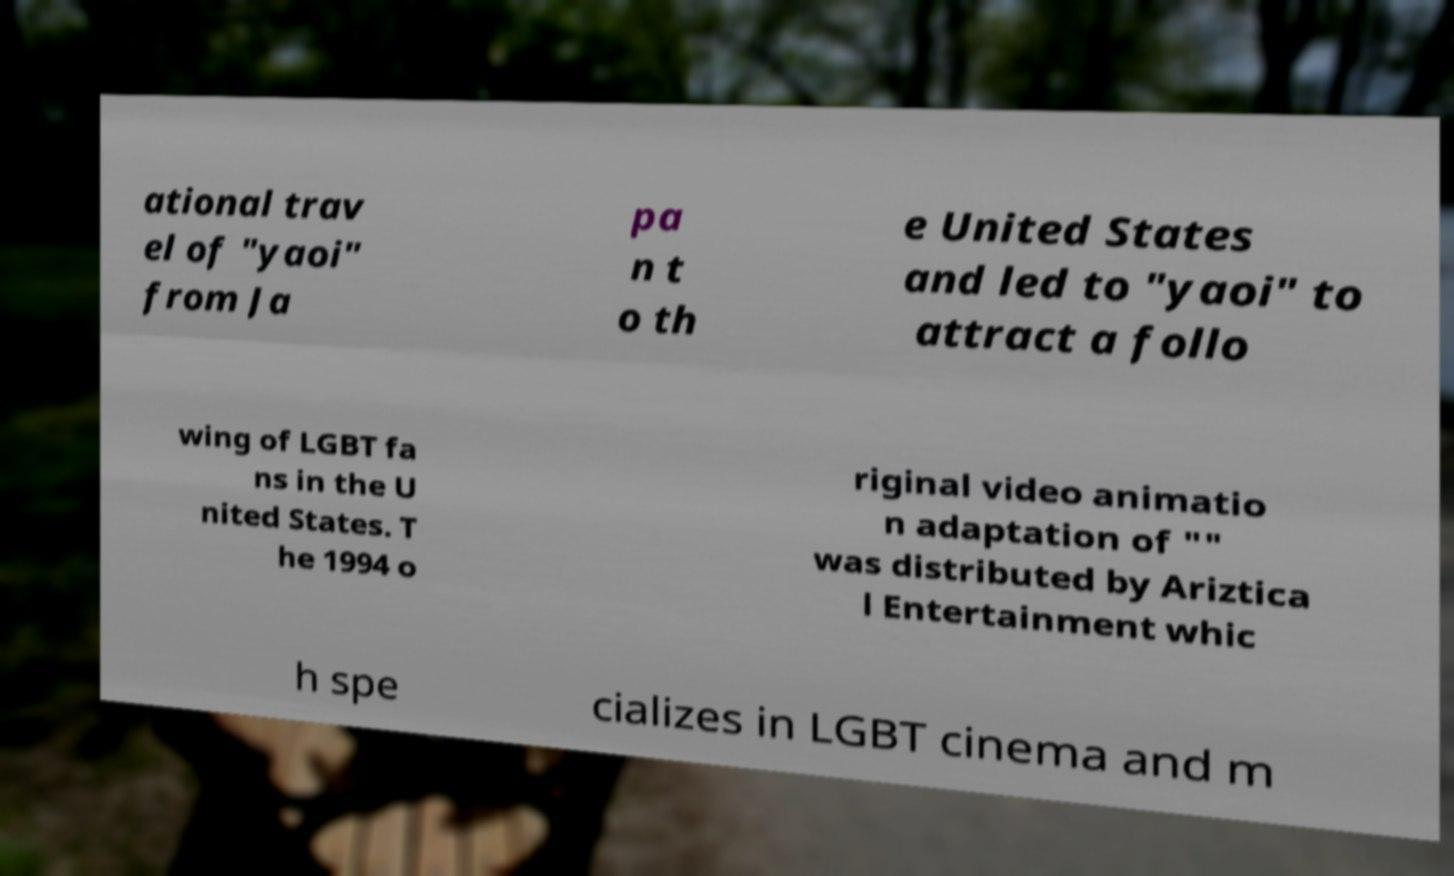What messages or text are displayed in this image? I need them in a readable, typed format. ational trav el of "yaoi" from Ja pa n t o th e United States and led to "yaoi" to attract a follo wing of LGBT fa ns in the U nited States. T he 1994 o riginal video animatio n adaptation of "" was distributed by Ariztica l Entertainment whic h spe cializes in LGBT cinema and m 